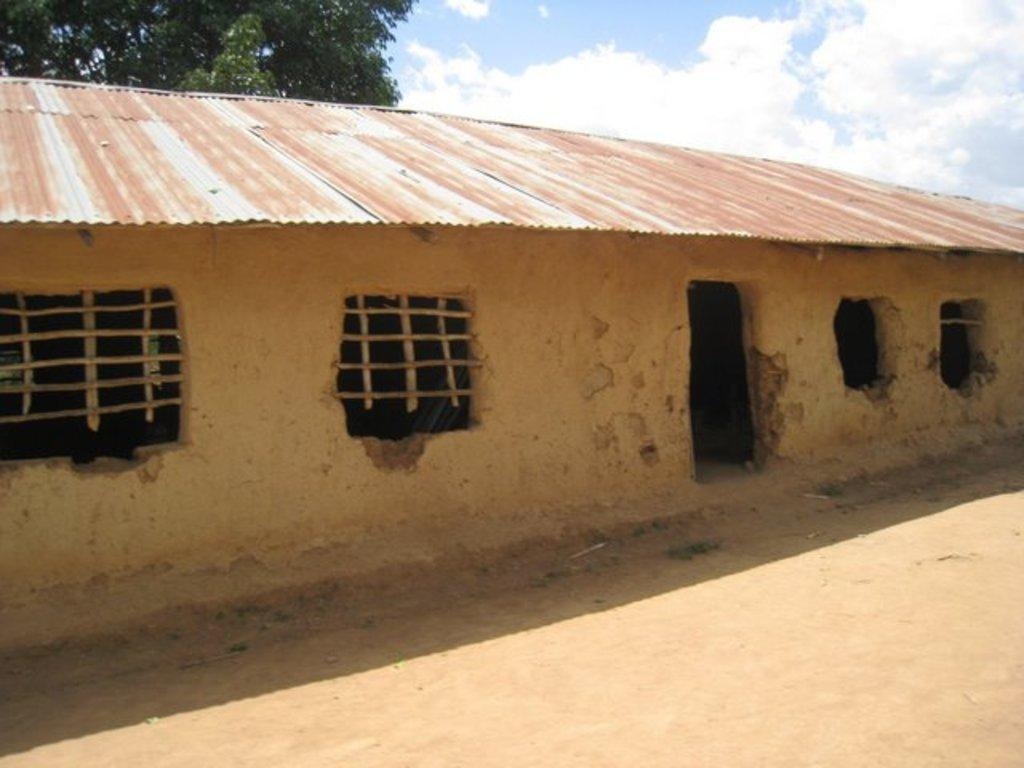What type of structure can be seen in the image? There is a shed in the image. What is visible beneath the shed? The ground is visible in the image. What type of vegetation is present in the image? There are trees in the image. What is visible above the shed and trees? The sky is visible in the image. What can be seen in the sky? Clouds are present in the sky. How does the sky fold in the image? The sky does not fold in the image; it remains as a continuous expanse above the shed, trees, and ground. 